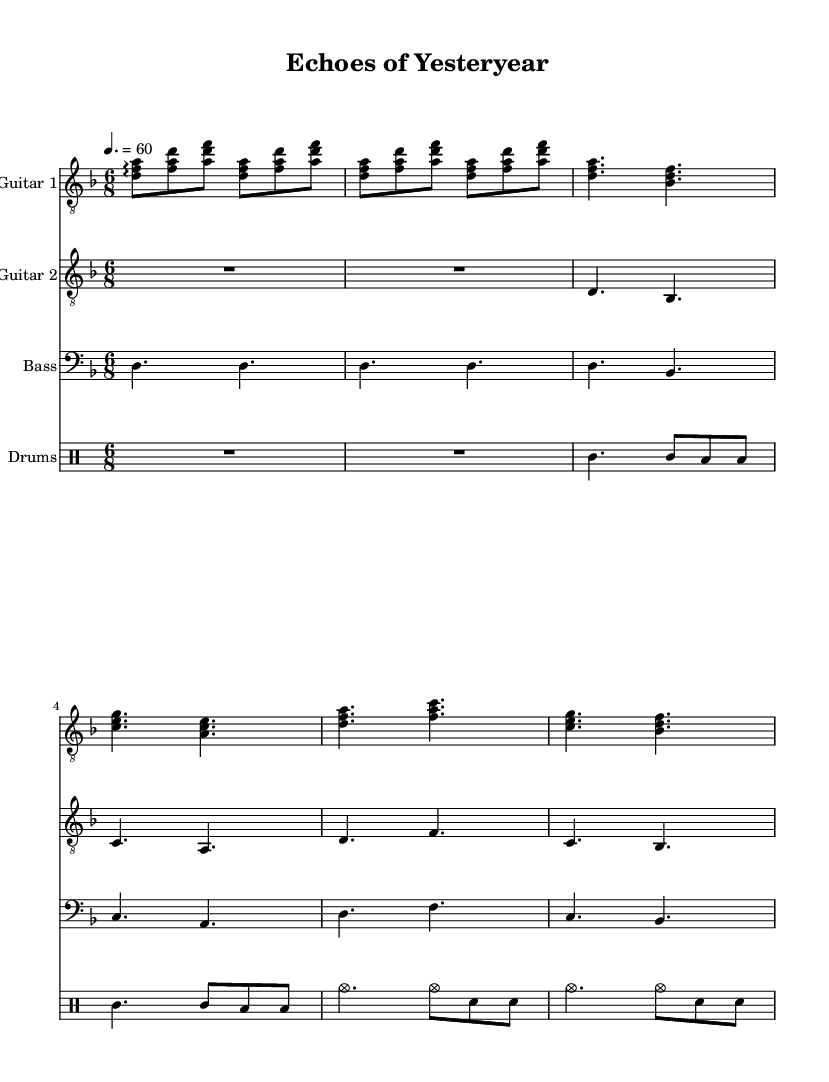What is the key signature of this music? The key signature is D minor, which has one flat (B flat). This can be identified at the beginning of the sheet music where the key signature is notated.
Answer: D minor What is the time signature of the piece? The time signature is 6/8, which indicates that there are six eighth notes per measure. This is visible at the beginning of the score where the time signature is placed.
Answer: 6/8 What is the tempo marking of this music? The tempo marking is quarter note equals 60. This indicates the speed of the piece, and it is noted at the beginning of the sheet music, providing a specific tempo indication.
Answer: 60 How many measures are present in the intro section? The intro section contains two measures, which can be seen clearly at the start of the guitar parts before moving on to the verse.
Answer: 2 Which instruments are featured in this score? The score features guitar one, guitar two, bass, and drums. This information is indicated at the top of each staff in the score, labeling the instruments.
Answer: Guitar 1, Guitar 2, Bass, Drums How does the structure reflect themes of nostalgia? The structure reflects themes of nostalgia through the use of arpeggiated chords in the intro and the emotional chord progressions in the verse and chorus, creating depth and resonance typical in progressive doom metal. The combination of these elements elicits feelings associated with reminiscing and the passage of time.
Answer: Emotional chord progressions 